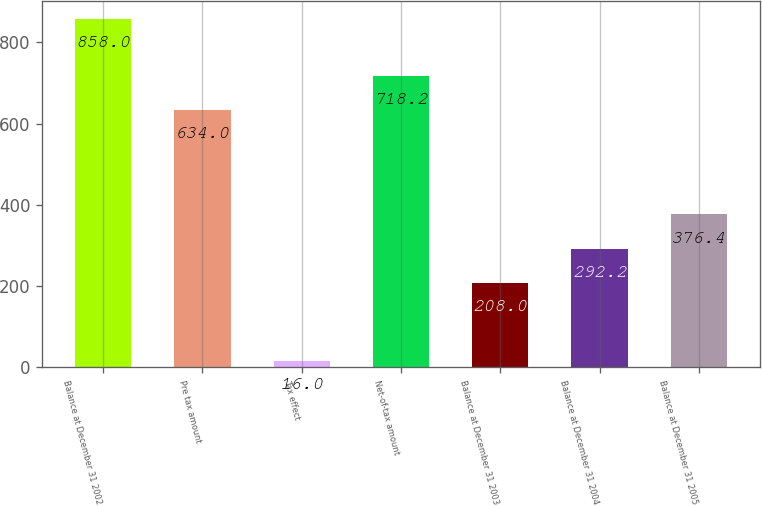<chart> <loc_0><loc_0><loc_500><loc_500><bar_chart><fcel>Balance at December 31 2002<fcel>Pre tax amount<fcel>Tax effect<fcel>Net-of-tax amount<fcel>Balance at December 31 2003<fcel>Balance at December 31 2004<fcel>Balance at December 31 2005<nl><fcel>858<fcel>634<fcel>16<fcel>718.2<fcel>208<fcel>292.2<fcel>376.4<nl></chart> 